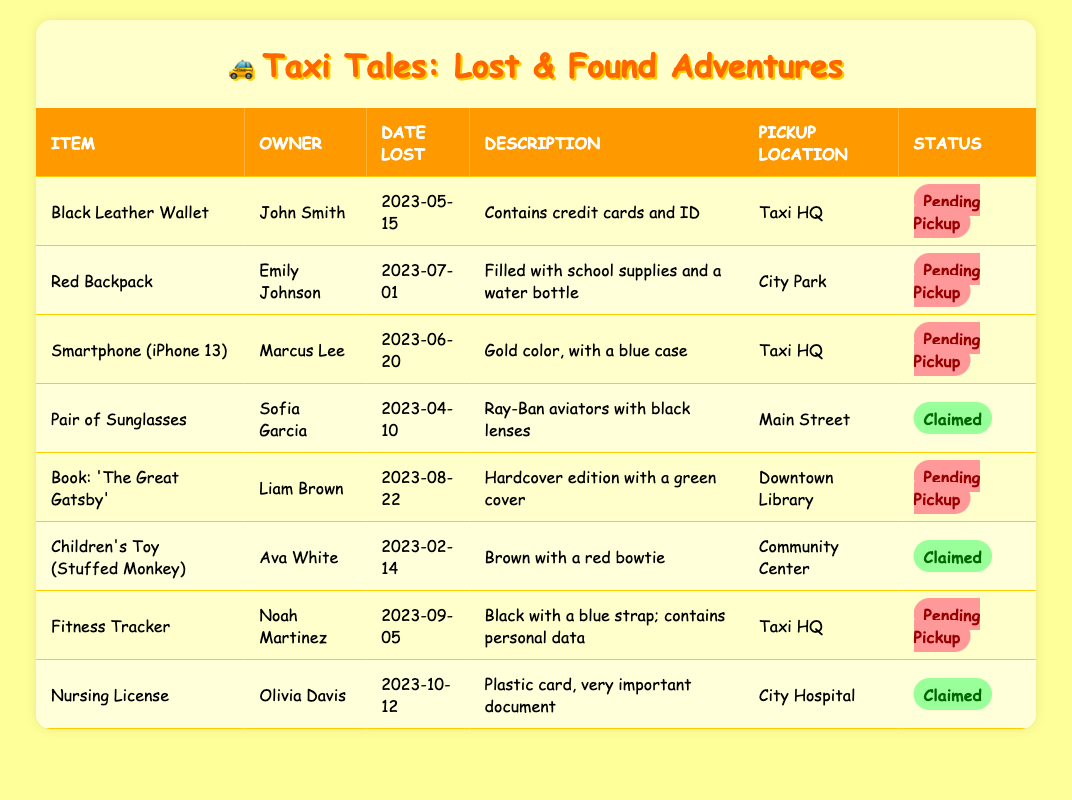What item was lost by Marcus Lee? Referring to the table, Marcus Lee's item name listed is "Smartphone (iPhone 13)."
Answer: Smartphone (iPhone 13) Which items are still pending pickup? To answer this, we look at the status of each item in the table. The items with "Pending Pickup" status are: Black Leather Wallet, Red Backpack, Smartphone (iPhone 13), Book: 'The Great Gatsby', and Fitness Tracker.
Answer: Black Leather Wallet, Red Backpack, Smartphone (iPhone 13), Book: 'The Great Gatsby', Fitness Tracker How many items have been claimed? By reviewing the table, we find that two items have the status "Claimed": Pair of Sunglasses and Nursing License. Therefore, the number of claimed items is 2.
Answer: 2 Is there a lost item that is a toy? Looking through the table, the item described as a toy is "Children's Toy (Stuffed Monkey," and it shows a status of Claimed, which confirms its existence.
Answer: Yes When was the Red Backpack lost? By checking the date lost column in the table, the Red Backpack was lost on "2023-07-01."
Answer: 2023-07-01 Which item has the most recent date lost? We review the date lost for all items. The latest date is "2023-10-12" for the Nursing License, identifying it as the most recently lost item.
Answer: Nursing License What is the total number of items listed in the table? We count the rows in the table, which reveals that there are 8 items total listed in the inventory.
Answer: 8 Which owner lost an item at Taxi HQ? Observing the table, the owners with items lost at Taxi HQ are John Smith (Black Leather Wallet), Marcus Lee (Smartphone), and Noah Martinez (Fitness Tracker).
Answer: John Smith, Marcus Lee, Noah Martinez 